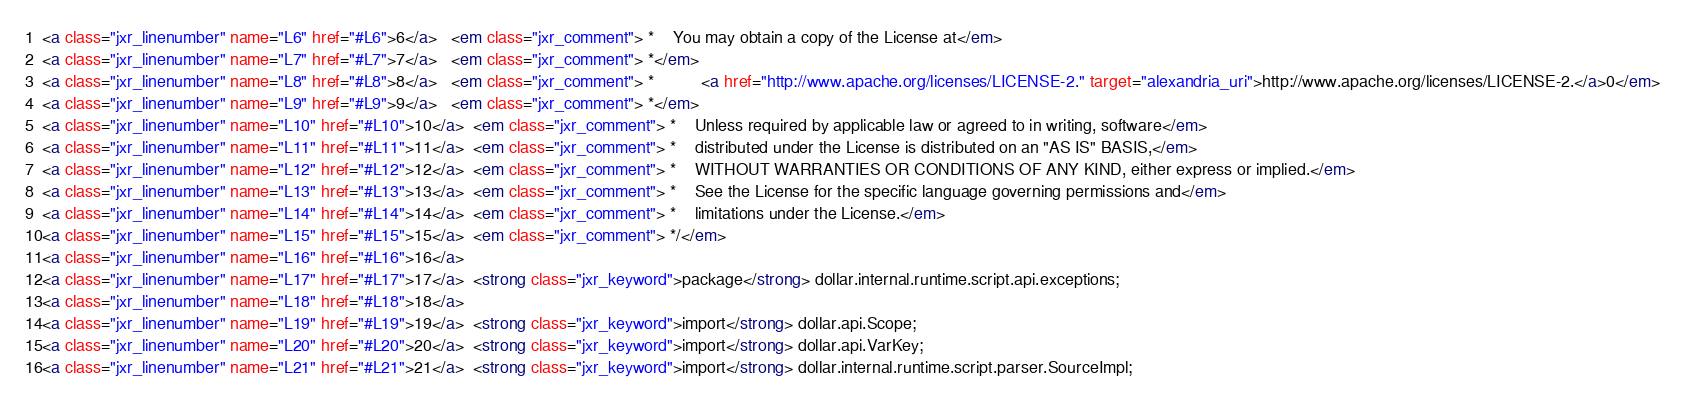<code> <loc_0><loc_0><loc_500><loc_500><_HTML_><a class="jxr_linenumber" name="L6" href="#L6">6</a>   <em class="jxr_comment"> *    You may obtain a copy of the License at</em>
<a class="jxr_linenumber" name="L7" href="#L7">7</a>   <em class="jxr_comment"> *</em>
<a class="jxr_linenumber" name="L8" href="#L8">8</a>   <em class="jxr_comment"> *          <a href="http://www.apache.org/licenses/LICENSE-2." target="alexandria_uri">http://www.apache.org/licenses/LICENSE-2.</a>0</em>
<a class="jxr_linenumber" name="L9" href="#L9">9</a>   <em class="jxr_comment"> *</em>
<a class="jxr_linenumber" name="L10" href="#L10">10</a>  <em class="jxr_comment"> *    Unless required by applicable law or agreed to in writing, software</em>
<a class="jxr_linenumber" name="L11" href="#L11">11</a>  <em class="jxr_comment"> *    distributed under the License is distributed on an "AS IS" BASIS,</em>
<a class="jxr_linenumber" name="L12" href="#L12">12</a>  <em class="jxr_comment"> *    WITHOUT WARRANTIES OR CONDITIONS OF ANY KIND, either express or implied.</em>
<a class="jxr_linenumber" name="L13" href="#L13">13</a>  <em class="jxr_comment"> *    See the License for the specific language governing permissions and</em>
<a class="jxr_linenumber" name="L14" href="#L14">14</a>  <em class="jxr_comment"> *    limitations under the License.</em>
<a class="jxr_linenumber" name="L15" href="#L15">15</a>  <em class="jxr_comment"> */</em>
<a class="jxr_linenumber" name="L16" href="#L16">16</a>  
<a class="jxr_linenumber" name="L17" href="#L17">17</a>  <strong class="jxr_keyword">package</strong> dollar.internal.runtime.script.api.exceptions;
<a class="jxr_linenumber" name="L18" href="#L18">18</a>  
<a class="jxr_linenumber" name="L19" href="#L19">19</a>  <strong class="jxr_keyword">import</strong> dollar.api.Scope;
<a class="jxr_linenumber" name="L20" href="#L20">20</a>  <strong class="jxr_keyword">import</strong> dollar.api.VarKey;
<a class="jxr_linenumber" name="L21" href="#L21">21</a>  <strong class="jxr_keyword">import</strong> dollar.internal.runtime.script.parser.SourceImpl;</code> 